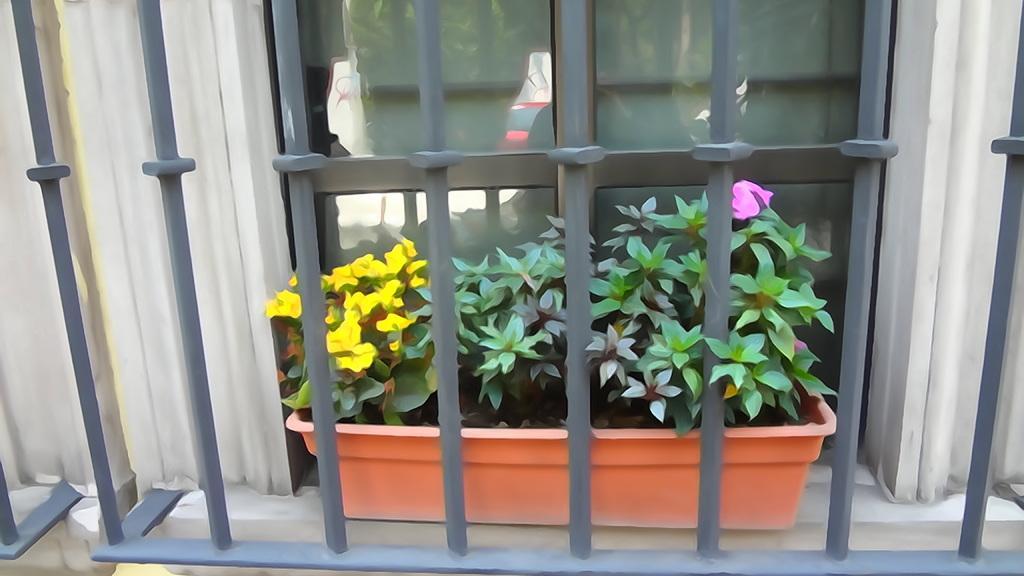Could you give a brief overview of what you see in this image? In the image we can see a fencing. through the fencing we can see a plant and glass window. 